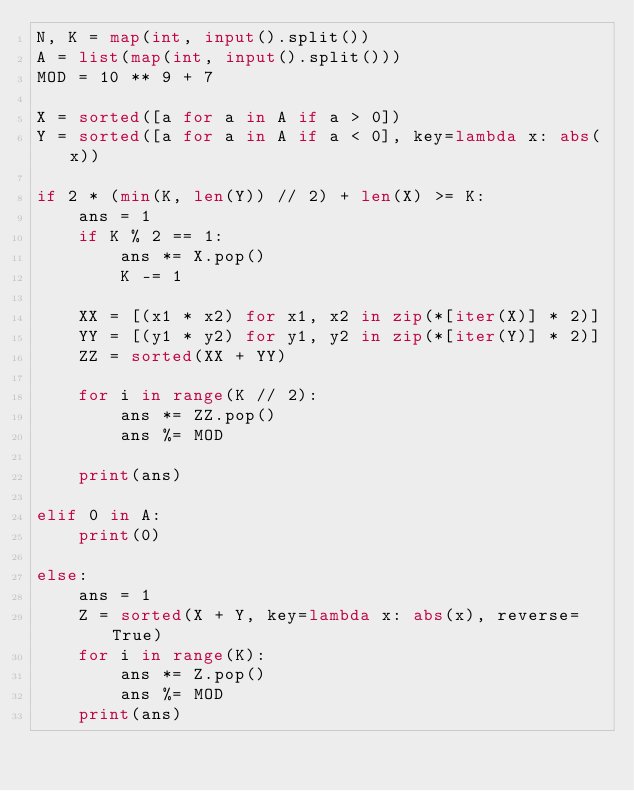<code> <loc_0><loc_0><loc_500><loc_500><_Python_>N, K = map(int, input().split())
A = list(map(int, input().split()))
MOD = 10 ** 9 + 7

X = sorted([a for a in A if a > 0])
Y = sorted([a for a in A if a < 0], key=lambda x: abs(x))

if 2 * (min(K, len(Y)) // 2) + len(X) >= K:
    ans = 1
    if K % 2 == 1:
        ans *= X.pop()
        K -= 1

    XX = [(x1 * x2) for x1, x2 in zip(*[iter(X)] * 2)]
    YY = [(y1 * y2) for y1, y2 in zip(*[iter(Y)] * 2)]
    ZZ = sorted(XX + YY)

    for i in range(K // 2):
        ans *= ZZ.pop()
        ans %= MOD

    print(ans)

elif 0 in A:
    print(0)

else:
    ans = 1
    Z = sorted(X + Y, key=lambda x: abs(x), reverse=True)
    for i in range(K):
        ans *= Z.pop()
        ans %= MOD
    print(ans)
</code> 